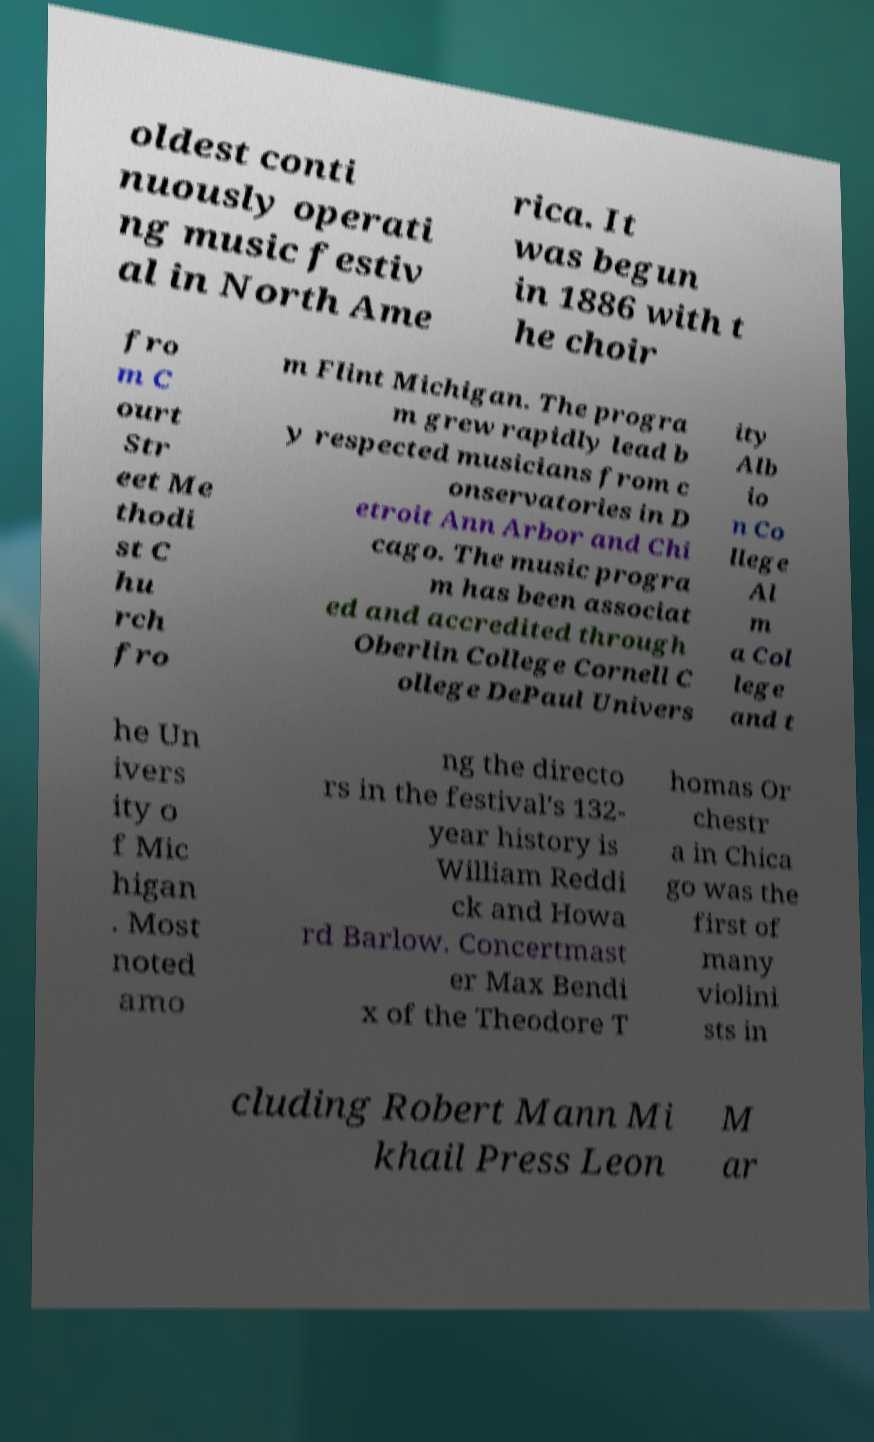Please identify and transcribe the text found in this image. oldest conti nuously operati ng music festiv al in North Ame rica. It was begun in 1886 with t he choir fro m C ourt Str eet Me thodi st C hu rch fro m Flint Michigan. The progra m grew rapidly lead b y respected musicians from c onservatories in D etroit Ann Arbor and Chi cago. The music progra m has been associat ed and accredited through Oberlin College Cornell C ollege DePaul Univers ity Alb io n Co llege Al m a Col lege and t he Un ivers ity o f Mic higan . Most noted amo ng the directo rs in the festival's 132- year history is William Reddi ck and Howa rd Barlow. Concertmast er Max Bendi x of the Theodore T homas Or chestr a in Chica go was the first of many violini sts in cluding Robert Mann Mi khail Press Leon M ar 